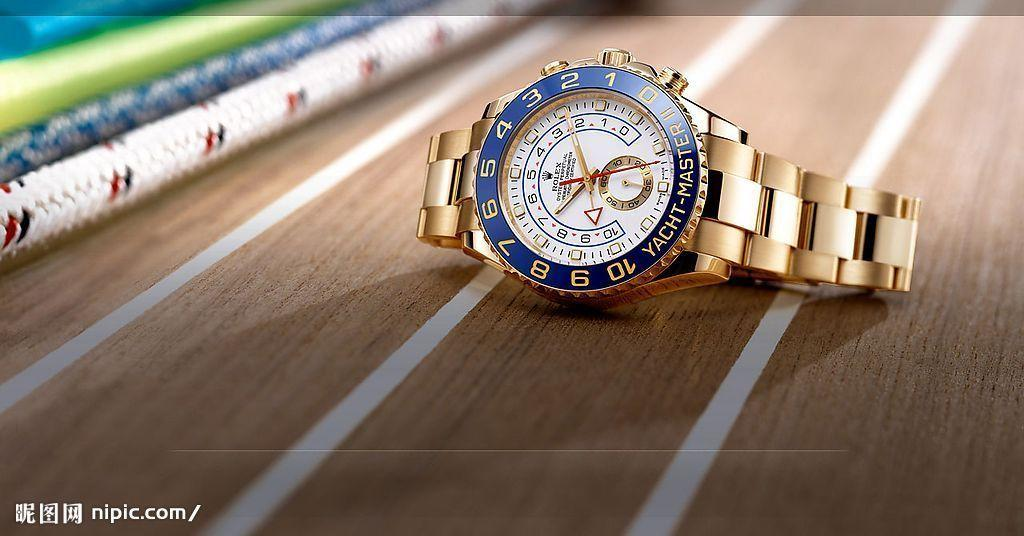Provide a one-sentence caption for the provided image. A Rolex watch points to the space between the numbers 2 and 3. 